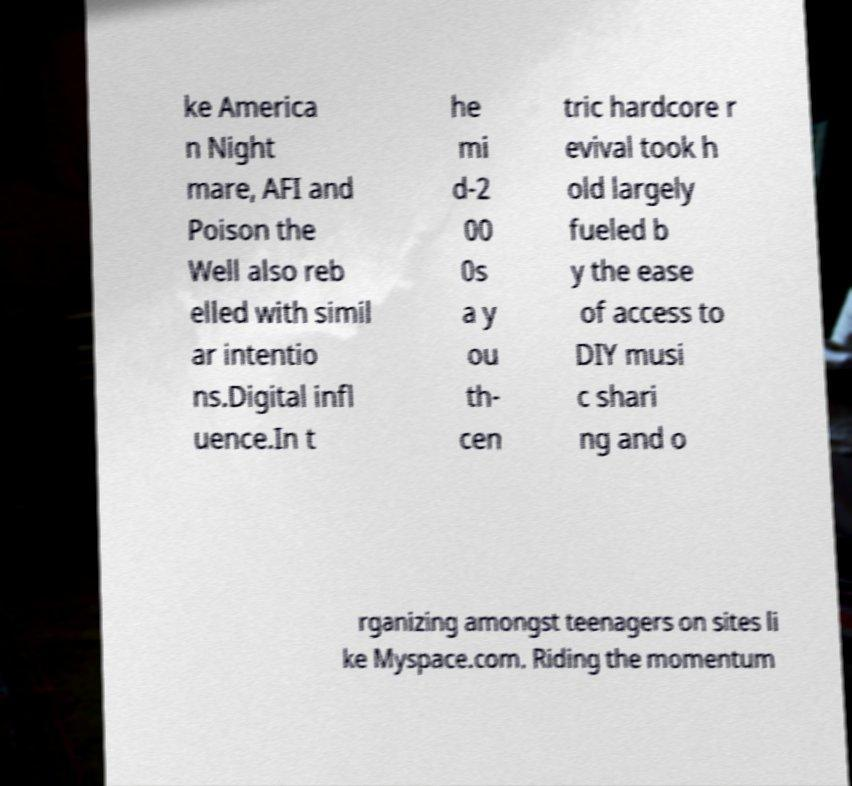Can you accurately transcribe the text from the provided image for me? ke America n Night mare, AFI and Poison the Well also reb elled with simil ar intentio ns.Digital infl uence.In t he mi d-2 00 0s a y ou th- cen tric hardcore r evival took h old largely fueled b y the ease of access to DIY musi c shari ng and o rganizing amongst teenagers on sites li ke Myspace.com. Riding the momentum 